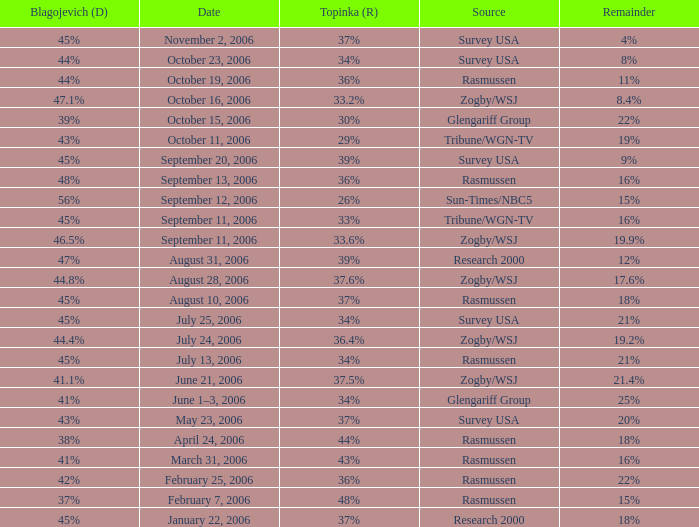Which Blagojevich (D) has a Source of zogby/wsj, and a Date of october 16, 2006? 47.1%. 